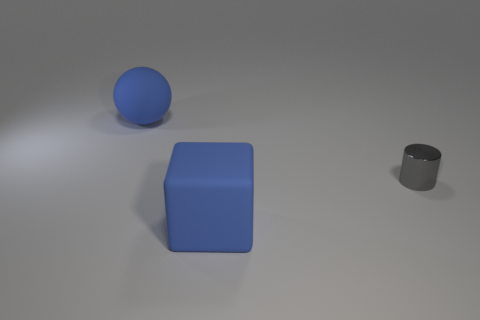There is a blue rubber object behind the large blue thing to the right of the rubber ball; is there a big blue matte thing that is behind it?
Keep it short and to the point. No. What size is the thing that is both in front of the large ball and left of the cylinder?
Make the answer very short. Large. What number of large blue spheres have the same material as the small cylinder?
Ensure brevity in your answer.  0. What number of balls are gray things or blue objects?
Your answer should be very brief. 1. What is the size of the rubber object in front of the blue rubber object left of the large blue matte object that is in front of the tiny metallic object?
Keep it short and to the point. Large. There is a thing that is behind the big matte cube and to the left of the tiny shiny object; what color is it?
Your answer should be very brief. Blue. Is the size of the metallic thing the same as the blue thing in front of the small cylinder?
Offer a terse response. No. Are there any other things that are the same shape as the tiny metallic object?
Provide a short and direct response. No. Does the metal object have the same size as the cube?
Ensure brevity in your answer.  No. What number of other objects are the same size as the block?
Offer a very short reply. 1. 